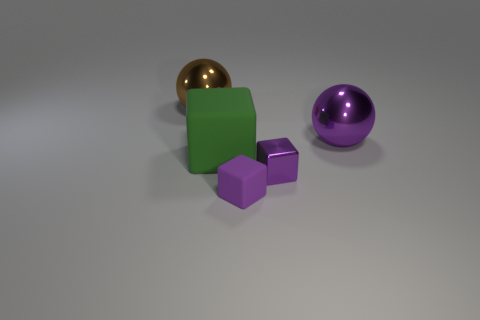The small thing that is the same color as the shiny block is what shape? cube 